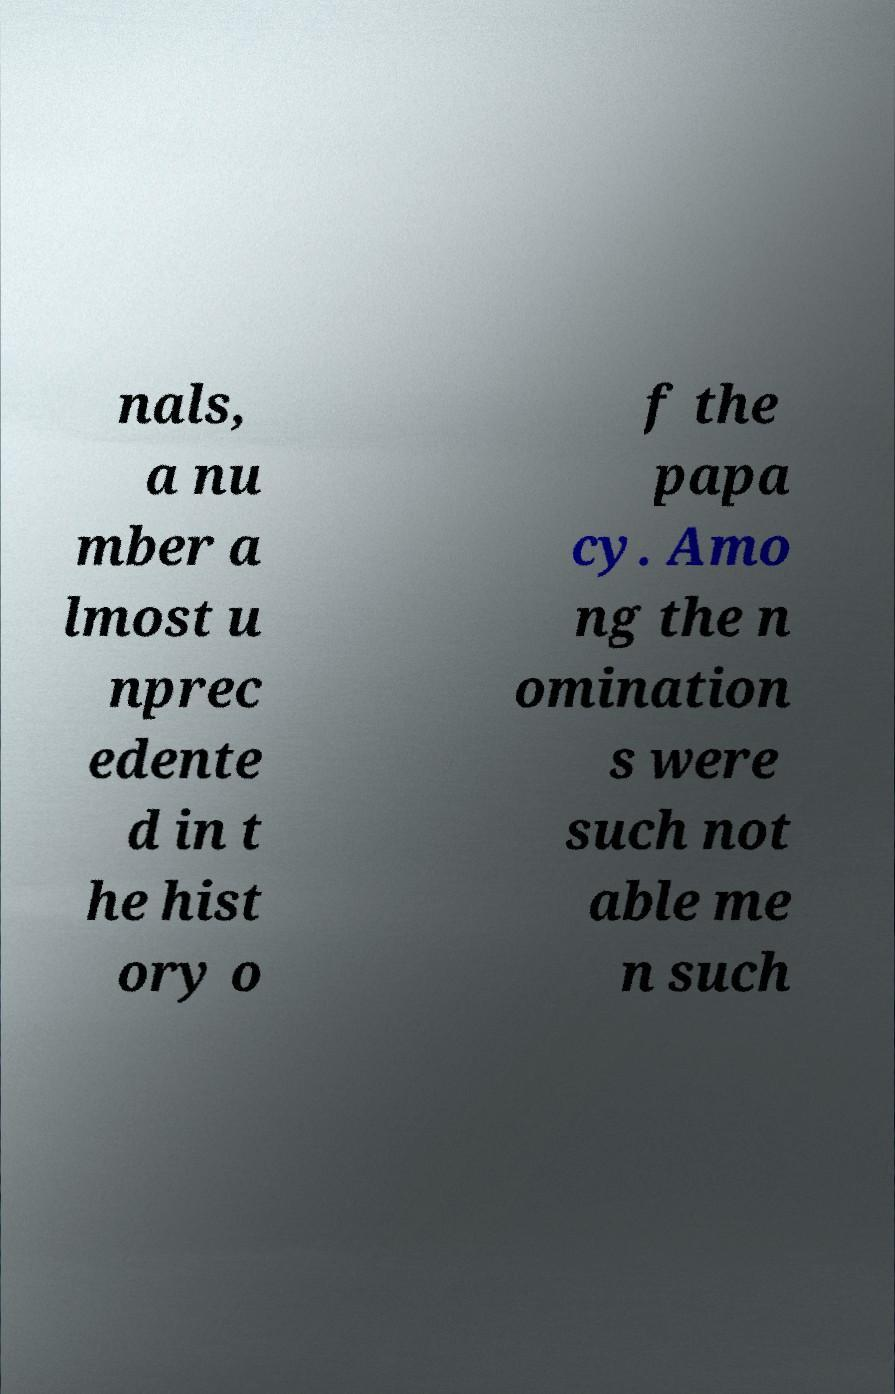Please read and relay the text visible in this image. What does it say? nals, a nu mber a lmost u nprec edente d in t he hist ory o f the papa cy. Amo ng the n omination s were such not able me n such 